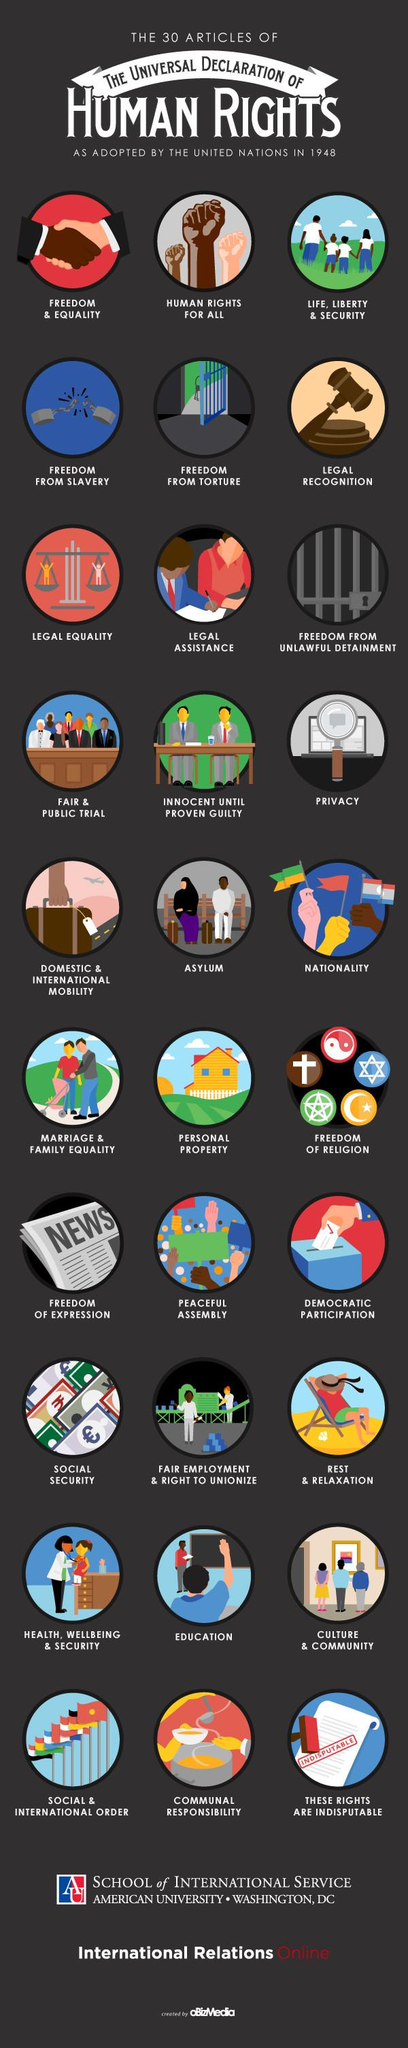Highlight a few significant elements in this photo. The Universal Declaration of Human Rights, as adopted by the United Nations in 1948, states in its 20th article that the right to peaceful assembly shall be recognized. The Universal Declaration of Human Rights, adopted by the United Nations in 1948, states in its 7th article that legal equality shall be guaranteed to all individuals. The 29th article of the Universal Declaration of Human Rights, as adopted by the United Nations in 1948, states that "communal responsibility" is a fundamental right. The 15th article of the Universal Declaration of Human Rights, as adopted by the United Nations in 1948, asserts that "Everyone has the right to a nationality. The 26th article of the Universal Declaration of Human Rights, as adopted by the United Nations in 1948, is education. 